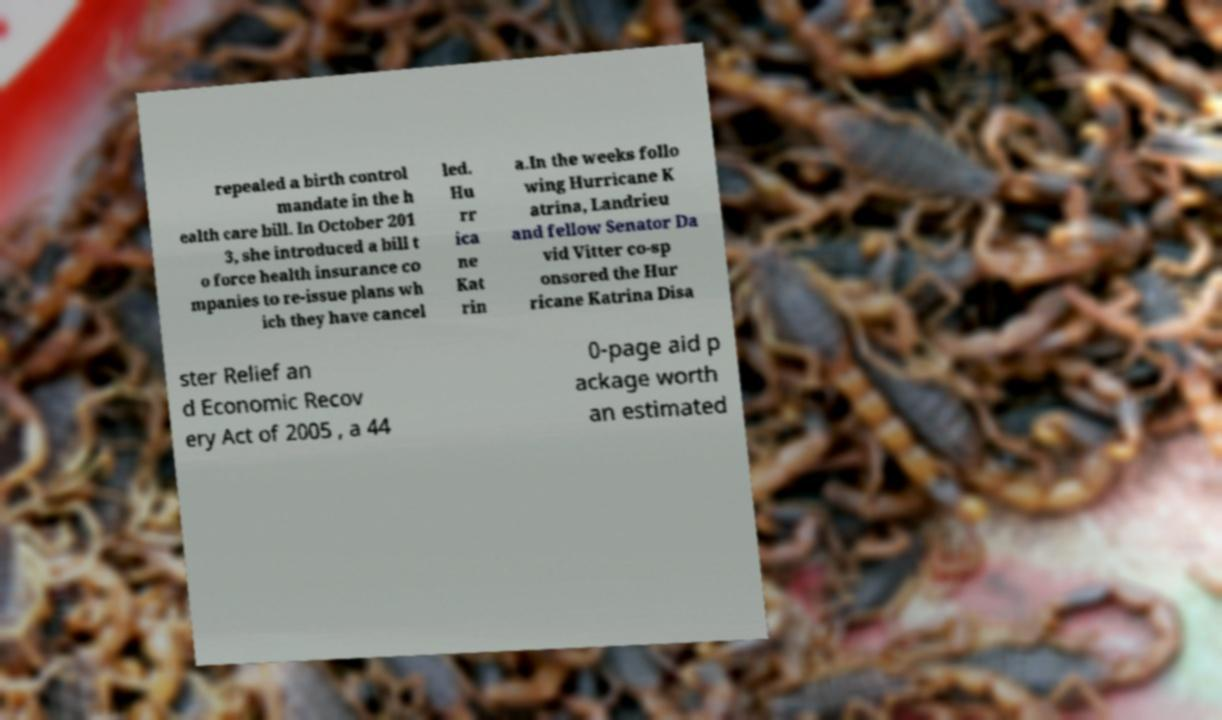Could you assist in decoding the text presented in this image and type it out clearly? repealed a birth control mandate in the h ealth care bill. In October 201 3, she introduced a bill t o force health insurance co mpanies to re-issue plans wh ich they have cancel led. Hu rr ica ne Kat rin a.In the weeks follo wing Hurricane K atrina, Landrieu and fellow Senator Da vid Vitter co-sp onsored the Hur ricane Katrina Disa ster Relief an d Economic Recov ery Act of 2005 , a 44 0-page aid p ackage worth an estimated 